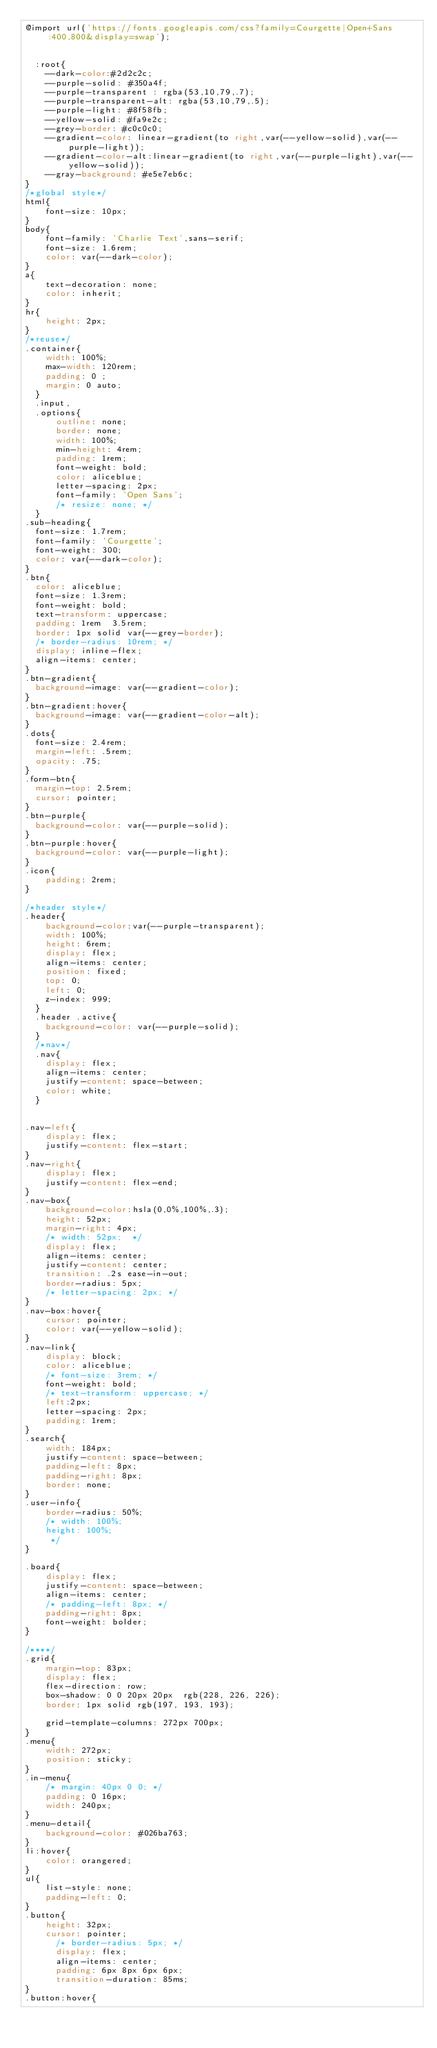<code> <loc_0><loc_0><loc_500><loc_500><_CSS_>@import url('https://fonts.googleapis.com/css?family=Courgette|Open+Sans:400,800&display=swap');


  :root{
    --dark-color:#2d2c2c;
    --purple-solid: #350a4f;
    --purple-transparent : rgba(53,10,79,.7);
    --purple-transparent-alt: rgba(53,10,79,.5);
    --purple-light: #8f58fb;
    --yellow-solid: #fa9e2c;
    --grey-border: #c0c0c0;
    --gradient-color: linear-gradient(to right,var(--yellow-solid),var(--purple-light));
    --gradient-color-alt:linear-gradient(to right,var(--purple-light),var(--yellow-solid));
    --gray-background: #e5e7eb6c;
}
/*global style*/
html{
    font-size: 10px;
}
body{
    font-family: 'Charlie Text',sans-serif;
    font-size: 1.6rem;
    color: var(--dark-color);
}
a{
    text-decoration: none;
    color: inherit;
}
hr{
    height: 2px;
}
/*reuse*/
.container{
    width: 100%;
    max-width: 120rem;
    padding: 0 ;
    margin: 0 auto;
  }
  .input,
  .options{
      outline: none;
      border: none;
      width: 100%;
      min-height: 4rem;
      padding: 1rem;
      font-weight: bold;
      color: aliceblue;
      letter-spacing: 2px;
      font-family: 'Open Sans';
      /* resize: none; */
  }
.sub-heading{
  font-size: 1.7rem;
  font-family: 'Courgette';
  font-weight: 300;
  color: var(--dark-color);
}
.btn{
  color: aliceblue;
  font-size: 1.3rem;
  font-weight: bold;
  text-transform: uppercase;
  padding: 1rem  3.5rem;
  border: 1px solid var(--grey-border);
  /* border-radius: 10rem; */
  display: inline-flex;
  align-items: center;
}
.btn-gradient{
  background-image: var(--gradient-color);
}
.btn-gradient:hover{
  background-image: var(--gradient-color-alt);
}
.dots{
  font-size: 2.4rem;
  margin-left: .5rem;
  opacity: .75;
}
.form-btn{
  margin-top: 2.5rem;
  cursor: pointer;
}
.btn-purple{
  background-color: var(--purple-solid);
}
.btn-purple:hover{
  background-color: var(--purple-light);
}
.icon{
    padding: 2rem;
}

/*header style*/
.header{
    background-color:var(--purple-transparent);
    width: 100%;
    height: 6rem;
    display: flex;
    align-items: center;
    position: fixed;
    top: 0;
    left: 0;
    z-index: 999;
  }
  .header .active{
    background-color: var(--purple-solid);
  }
  /*nav*/
  .nav{
    display: flex;
    align-items: center;
    justify-content: space-between;
    color: white;
  }


.nav-left{
    display: flex; 
    justify-content: flex-start;
}
.nav-right{
    display: flex; 
    justify-content: flex-end;
}
.nav-box{
    background-color:hsla(0,0%,100%,.3); 
    height: 52px;
    margin-right: 4px;
    /* width: 52px;  */
    display: flex;
    align-items: center;
    justify-content: center;
    transition: .2s ease-in-out;
    border-radius: 5px;
    /* letter-spacing: 2px; */
}
.nav-box:hover{
    cursor: pointer;
    color: var(--yellow-solid);
}
.nav-link{
    display: block;
    color: aliceblue;
    /* font-size: 3rem; */
    font-weight: bold;
    /* text-transform: uppercase; */
    left:2px;
    letter-spacing: 2px;
    padding: 1rem;
}
.search{
    width: 184px;
    justify-content: space-between;
    padding-left: 8px;
    padding-right: 8px;
    border: none;
}
.user-info{
    border-radius: 50%;
    /* width: 100%;
    height: 100%;
     */
}

.board{
    display: flex;
    justify-content: space-between;
    align-items: center;
    /* padding-left: 8px; */
    padding-right: 8px;
    font-weight: bolder;
}

/****/
.grid{
    margin-top: 83px;
    display: flex;
    flex-direction: row;
    box-shadow: 0 0 20px 20px  rgb(228, 226, 226);
    border: 1px solid rgb(197, 193, 193);
    
    grid-template-columns: 272px 700px;
}
.menu{
    width: 272px;
    position: sticky;
}
.in-menu{
    /* margin: 40px 0 0; */
    padding: 0 16px;
    width: 240px;
}
.menu-detail{
    background-color: #026ba763;
}
li:hover{
    color: orangered;
}
ul{
    list-style: none;
    padding-left: 0;
}
.button{
    height: 32px;
    cursor: pointer;  
      /* border-radius: 5px; */
      display: flex;
      align-items: center;
      padding: 6px 8px 6px 6px;
      transition-duration: 85ms;
}
.button:hover{</code> 